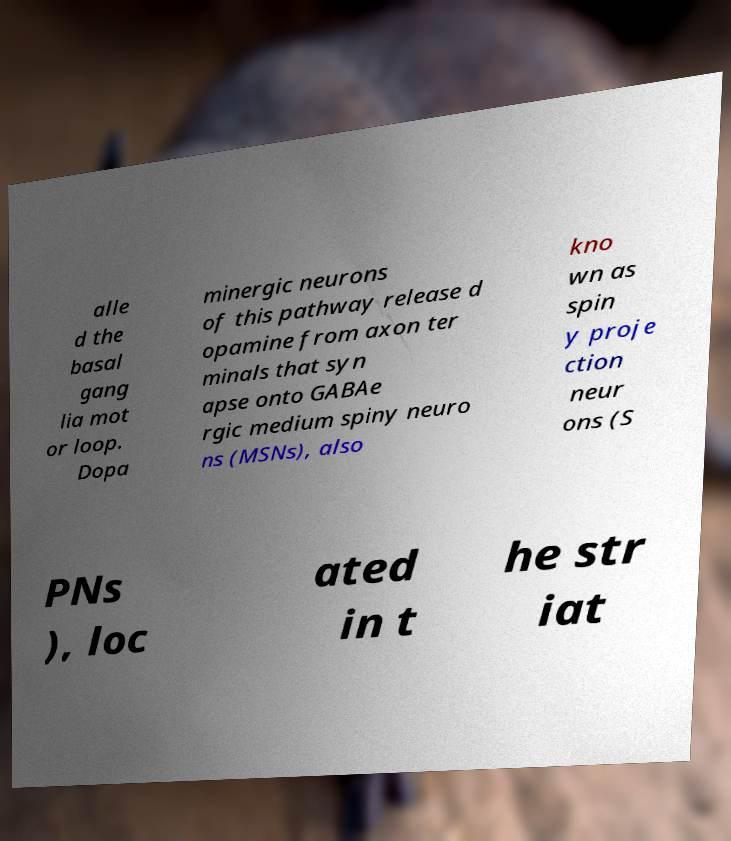What messages or text are displayed in this image? I need them in a readable, typed format. alle d the basal gang lia mot or loop. Dopa minergic neurons of this pathway release d opamine from axon ter minals that syn apse onto GABAe rgic medium spiny neuro ns (MSNs), also kno wn as spin y proje ction neur ons (S PNs ), loc ated in t he str iat 